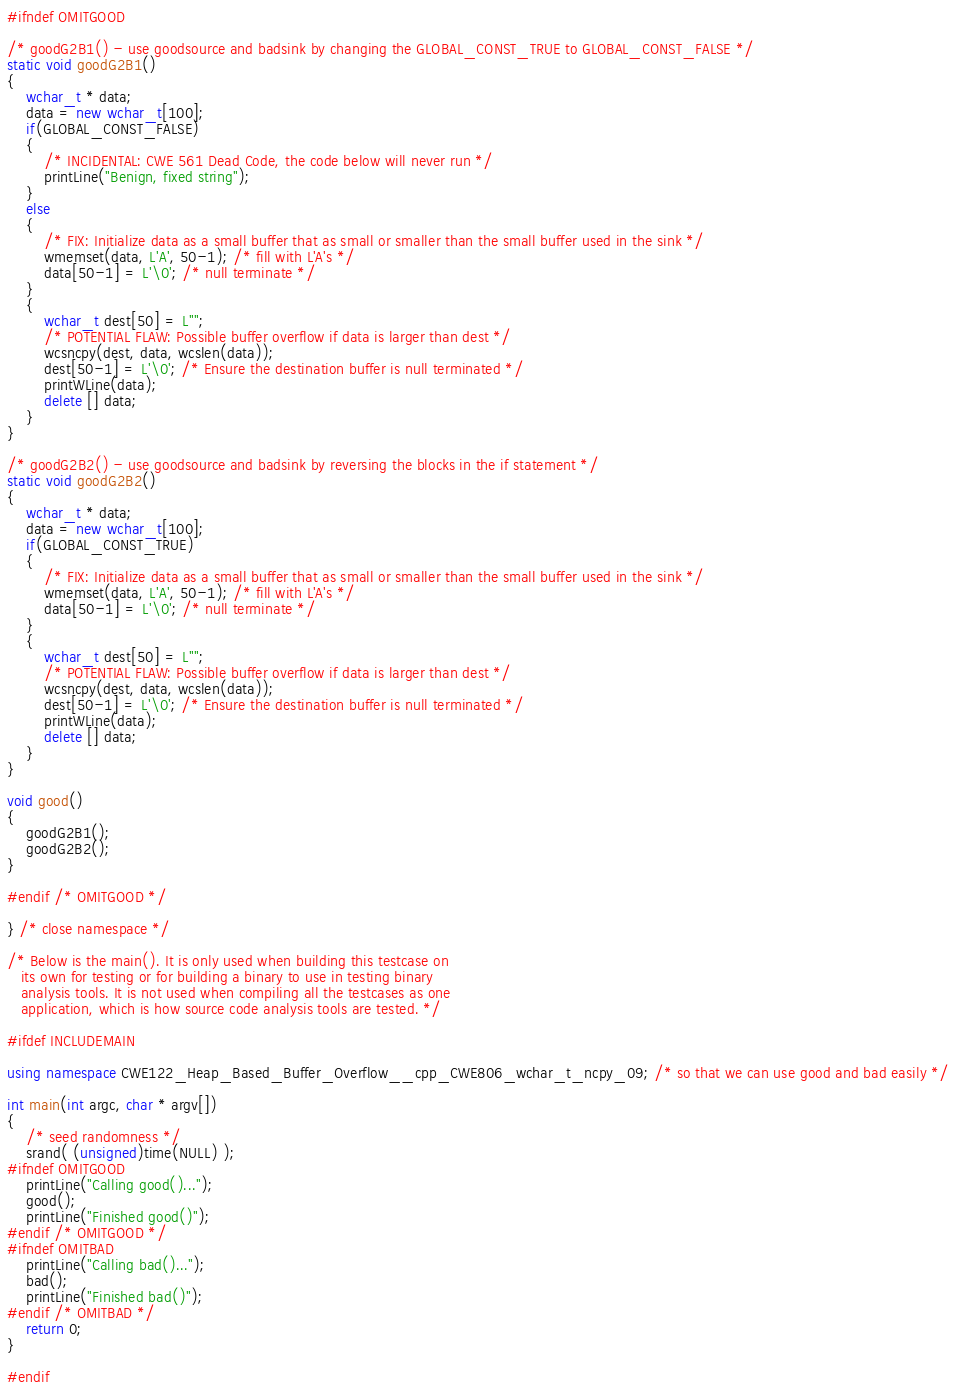<code> <loc_0><loc_0><loc_500><loc_500><_C++_>#ifndef OMITGOOD

/* goodG2B1() - use goodsource and badsink by changing the GLOBAL_CONST_TRUE to GLOBAL_CONST_FALSE */
static void goodG2B1()
{
    wchar_t * data;
    data = new wchar_t[100];
    if(GLOBAL_CONST_FALSE)
    {
        /* INCIDENTAL: CWE 561 Dead Code, the code below will never run */
        printLine("Benign, fixed string");
    }
    else
    {
        /* FIX: Initialize data as a small buffer that as small or smaller than the small buffer used in the sink */
        wmemset(data, L'A', 50-1); /* fill with L'A's */
        data[50-1] = L'\0'; /* null terminate */
    }
    {
        wchar_t dest[50] = L"";
        /* POTENTIAL FLAW: Possible buffer overflow if data is larger than dest */
        wcsncpy(dest, data, wcslen(data));
        dest[50-1] = L'\0'; /* Ensure the destination buffer is null terminated */
        printWLine(data);
        delete [] data;
    }
}

/* goodG2B2() - use goodsource and badsink by reversing the blocks in the if statement */
static void goodG2B2()
{
    wchar_t * data;
    data = new wchar_t[100];
    if(GLOBAL_CONST_TRUE)
    {
        /* FIX: Initialize data as a small buffer that as small or smaller than the small buffer used in the sink */
        wmemset(data, L'A', 50-1); /* fill with L'A's */
        data[50-1] = L'\0'; /* null terminate */
    }
    {
        wchar_t dest[50] = L"";
        /* POTENTIAL FLAW: Possible buffer overflow if data is larger than dest */
        wcsncpy(dest, data, wcslen(data));
        dest[50-1] = L'\0'; /* Ensure the destination buffer is null terminated */
        printWLine(data);
        delete [] data;
    }
}

void good()
{
    goodG2B1();
    goodG2B2();
}

#endif /* OMITGOOD */

} /* close namespace */

/* Below is the main(). It is only used when building this testcase on
   its own for testing or for building a binary to use in testing binary
   analysis tools. It is not used when compiling all the testcases as one
   application, which is how source code analysis tools are tested. */

#ifdef INCLUDEMAIN

using namespace CWE122_Heap_Based_Buffer_Overflow__cpp_CWE806_wchar_t_ncpy_09; /* so that we can use good and bad easily */

int main(int argc, char * argv[])
{
    /* seed randomness */
    srand( (unsigned)time(NULL) );
#ifndef OMITGOOD
    printLine("Calling good()...");
    good();
    printLine("Finished good()");
#endif /* OMITGOOD */
#ifndef OMITBAD
    printLine("Calling bad()...");
    bad();
    printLine("Finished bad()");
#endif /* OMITBAD */
    return 0;
}

#endif
</code> 